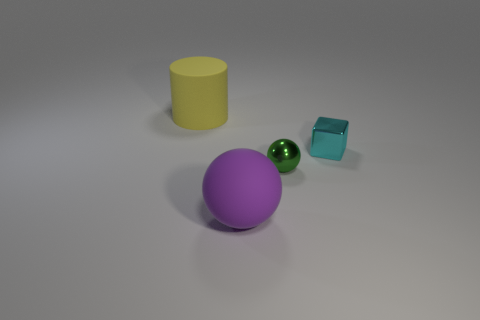Add 1 small yellow cubes. How many objects exist? 5 Subtract 1 balls. How many balls are left? 1 Subtract all blocks. How many objects are left? 3 Add 4 purple rubber balls. How many purple rubber balls are left? 5 Add 1 tiny red blocks. How many tiny red blocks exist? 1 Subtract 0 gray cubes. How many objects are left? 4 Subtract all red cubes. Subtract all red cylinders. How many cubes are left? 1 Subtract all rubber things. Subtract all large matte cylinders. How many objects are left? 1 